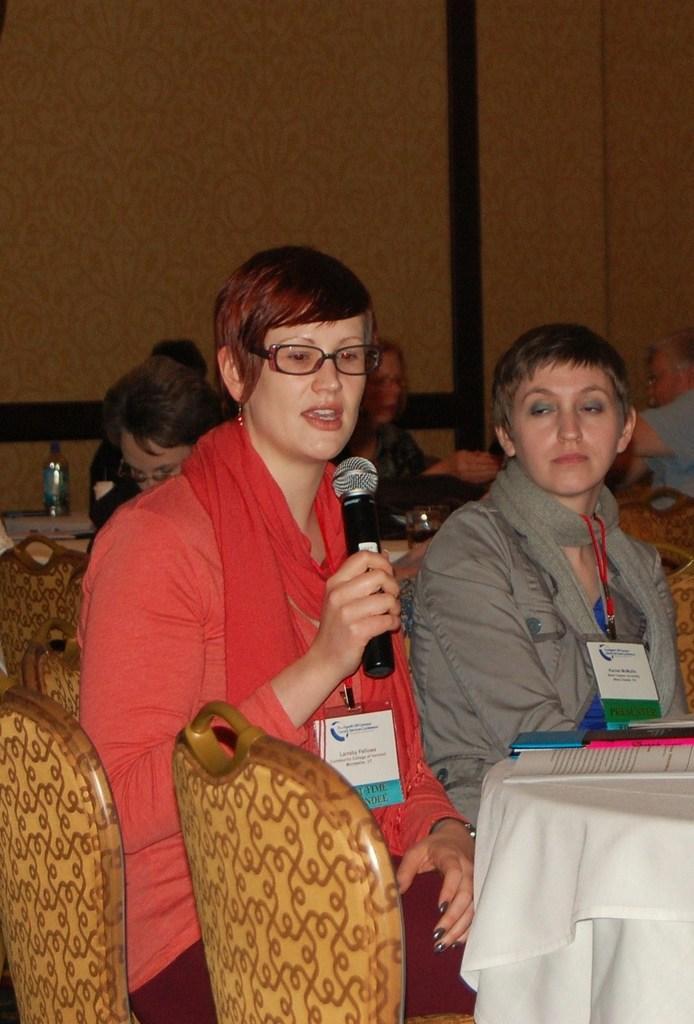In one or two sentences, can you explain what this image depicts? In this picture there is a woman with red dress is sitting and holding the microphone and she is talking and there are group of people sitting. There is a book and cellphone and bottle and there are objects on the table and tables are covered with white color clothes and there are chairs. At the back there is a wall. 